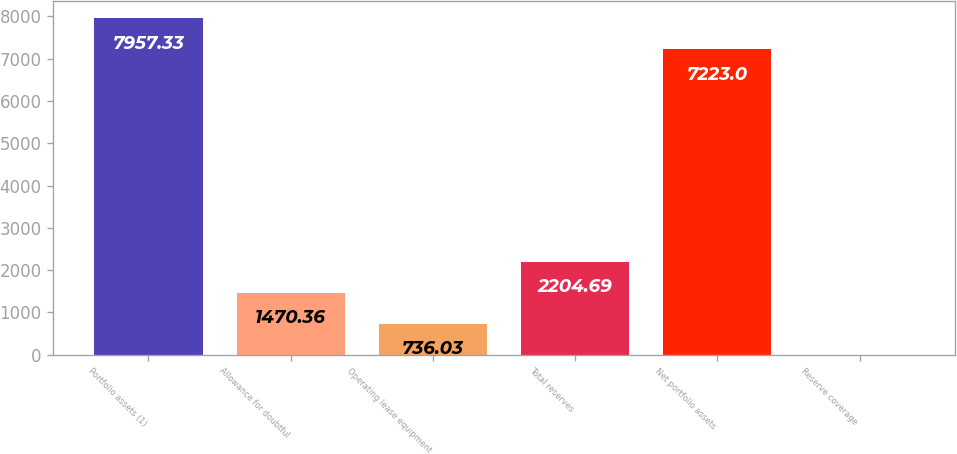Convert chart to OTSL. <chart><loc_0><loc_0><loc_500><loc_500><bar_chart><fcel>Portfolio assets (1)<fcel>Allowance for doubtful<fcel>Operating lease equipment<fcel>Total reserves<fcel>Net portfolio assets<fcel>Reserve coverage<nl><fcel>7957.33<fcel>1470.36<fcel>736.03<fcel>2204.69<fcel>7223<fcel>1.7<nl></chart> 